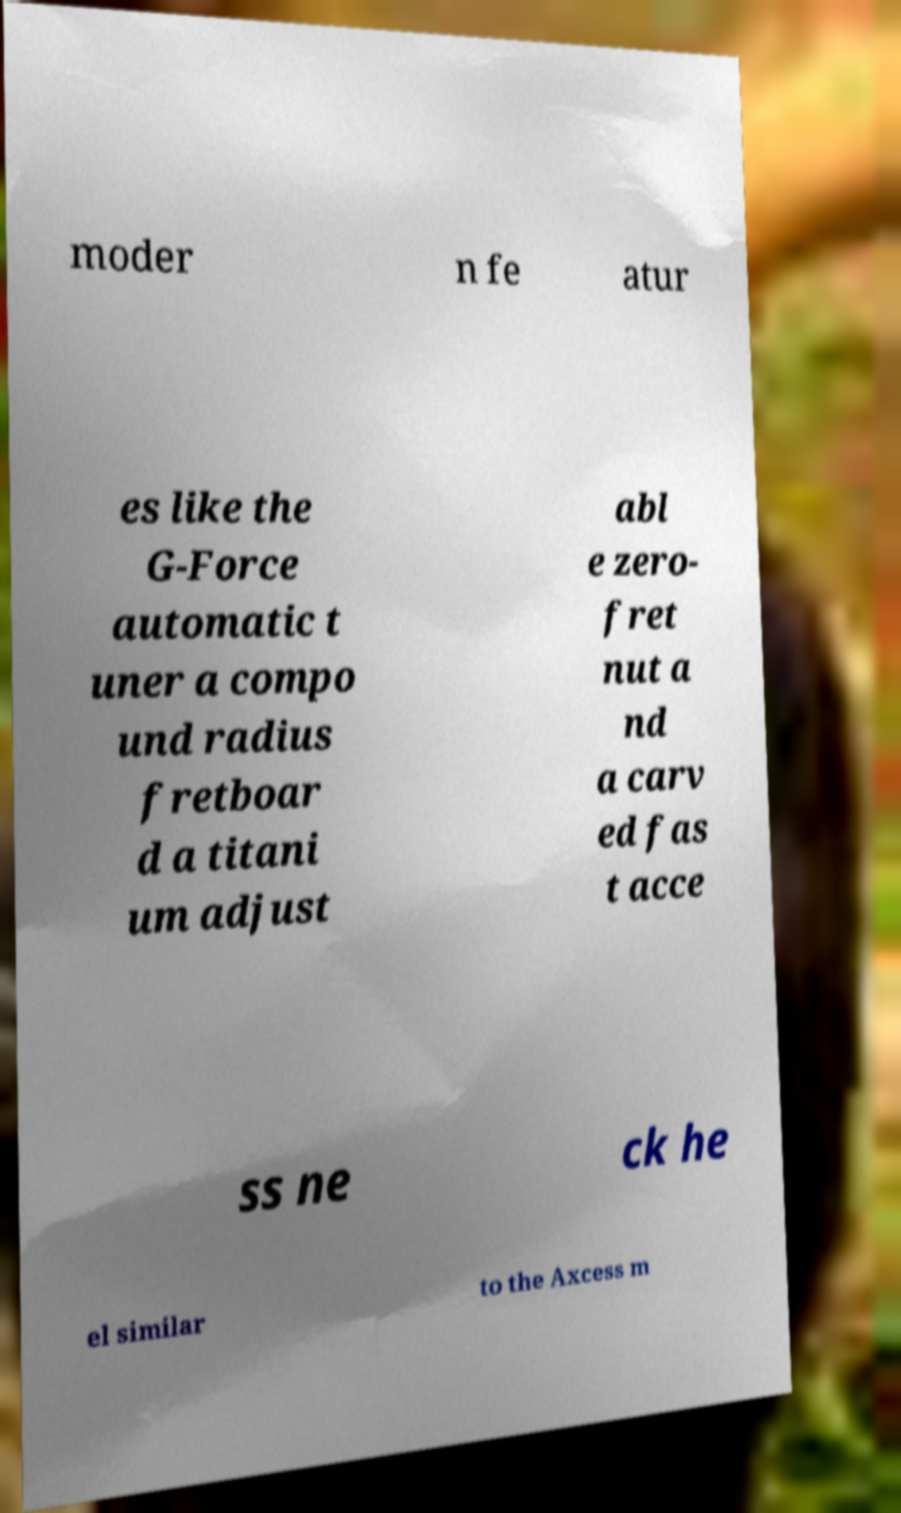There's text embedded in this image that I need extracted. Can you transcribe it verbatim? moder n fe atur es like the G-Force automatic t uner a compo und radius fretboar d a titani um adjust abl e zero- fret nut a nd a carv ed fas t acce ss ne ck he el similar to the Axcess m 